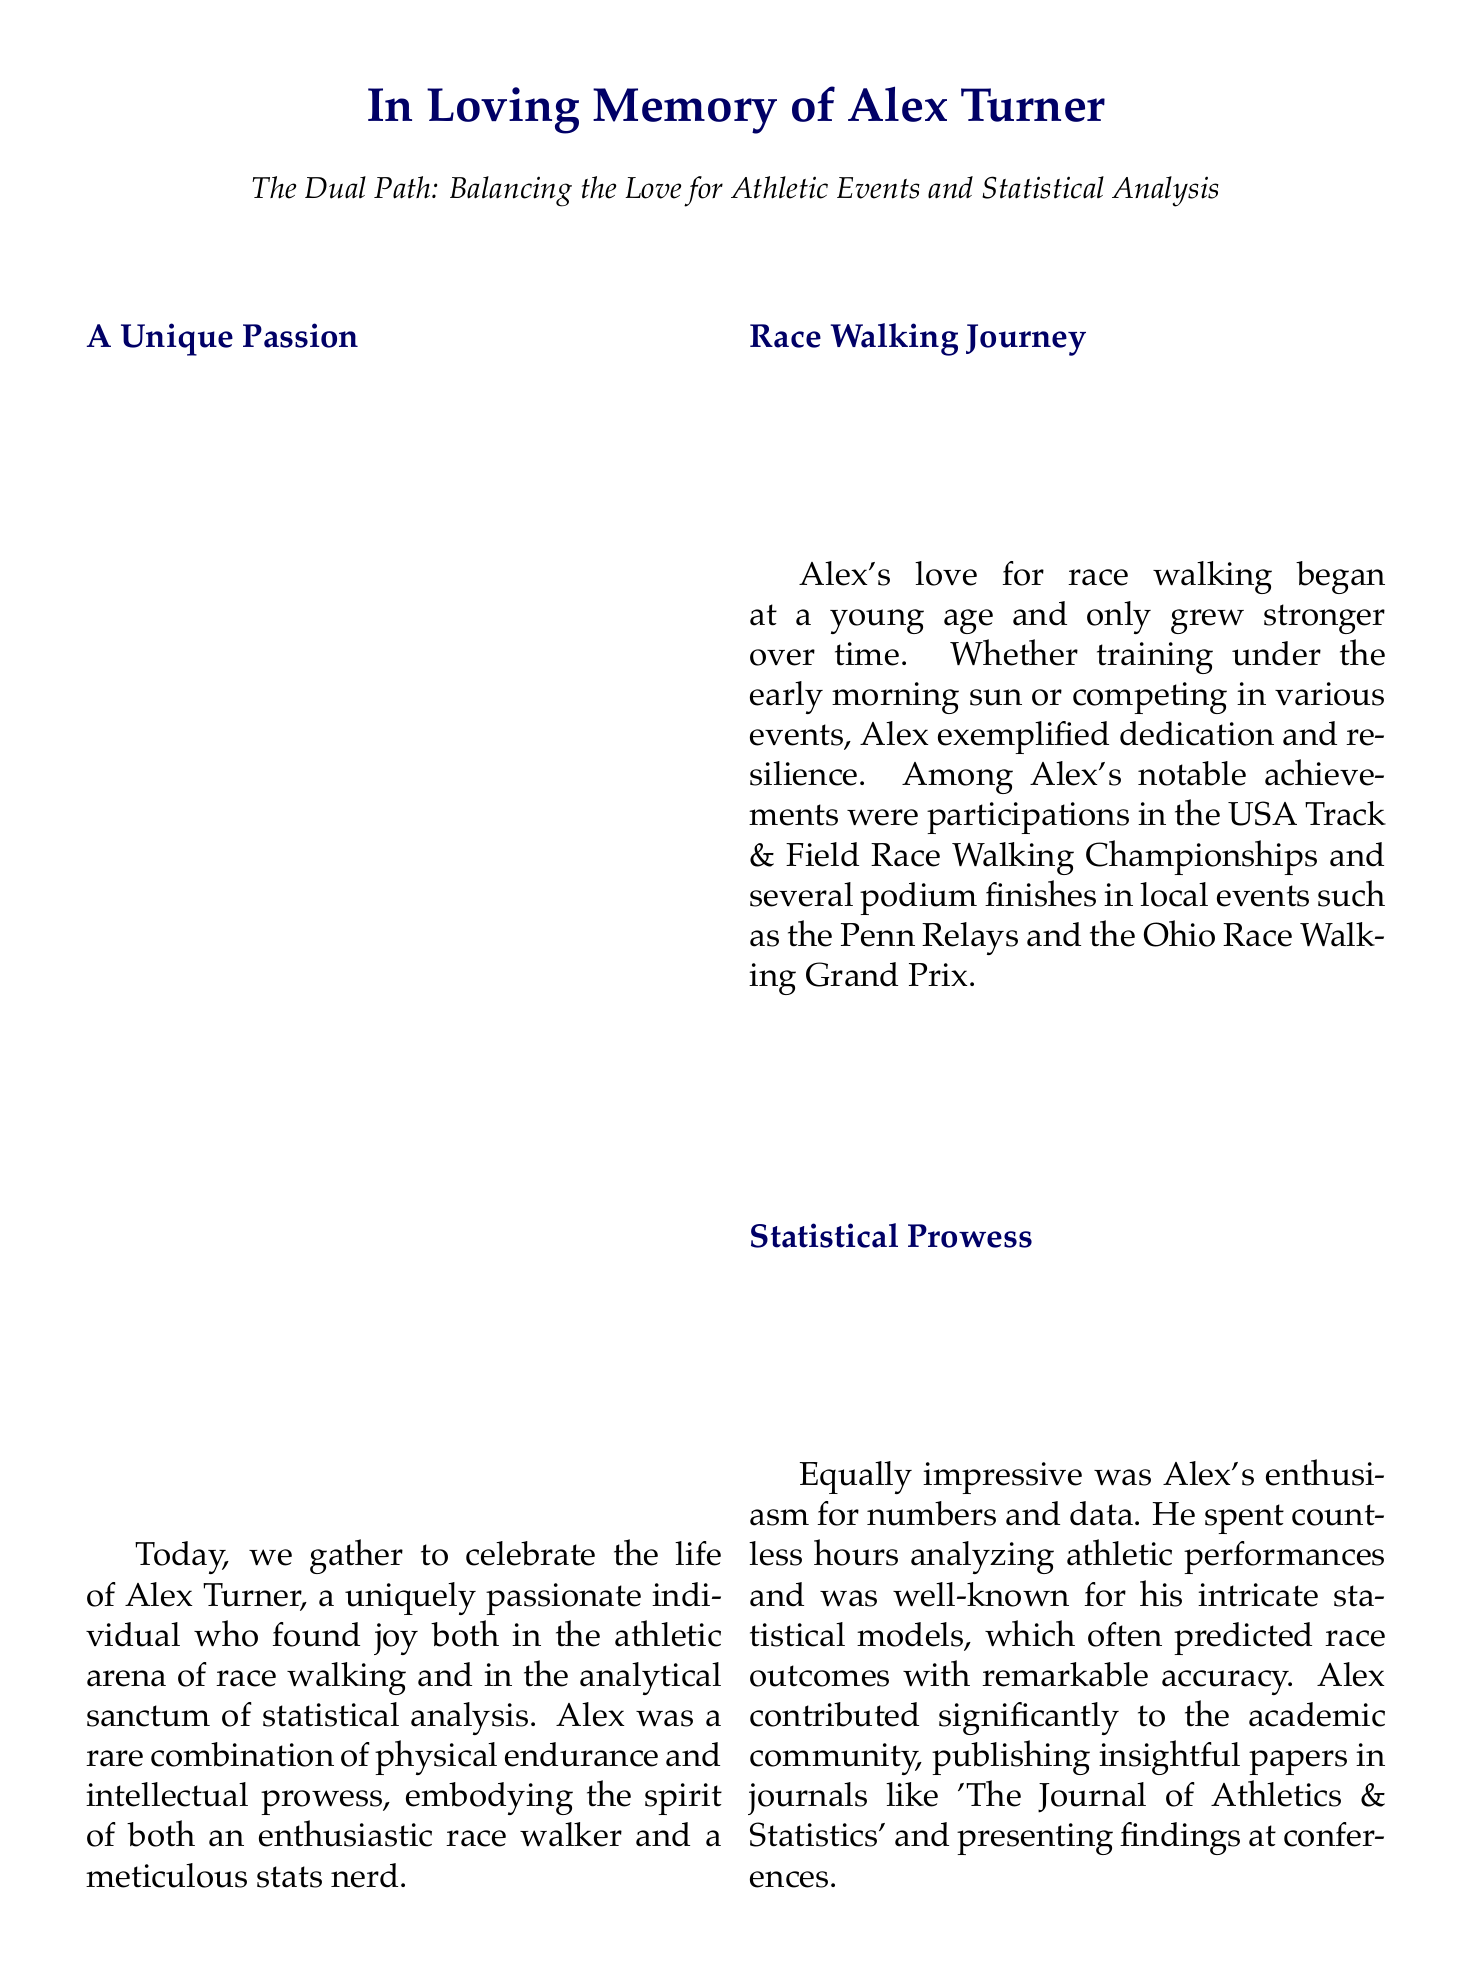What was Alex Turner's unique combination? Alex Turner was a combination of an enthusiastic race walker and a meticulous stats nerd.
Answer: Enthusiastic race walker and meticulous stats nerd In which race events did Alex participate? Alex participated in the USA Track & Field Race Walking Championships and local events like the Penn Relays and the Ohio Race Walking Grand Prix.
Answer: USA Track & Field Race Walking Championships, Penn Relays, Ohio Race Walking Grand Prix What did Alex often analyze? Alex often analyzed athletic performances and created intricate statistical models.
Answer: Athletic performances What tradition did Alex follow after races? Alex's post-race tradition was rushing home to input new data into his race performance spreadsheets.
Answer: Input new data into his race performance spreadsheets What scholarship did Alex's legacy support? Alex's legacy supports the 'Turner Scholarship for Athletic Excellence and Statistical Innovation.'
Answer: Turner Scholarship for Athletic Excellence and Statistical Innovation What did Alex exemplify in his life journey? Alex exemplified balancing passion and precision in his life journey.
Answer: Balancing passion and precision In which journals did Alex publish his papers? Alex published papers in journals like 'The Journal of Athletics & Statistics.'
Answer: The Journal of Athletics & Statistics Who did Alex mentor? Alex mentored aspiring athletes and analysts alike.
Answer: Aspiring athletes and analysts 